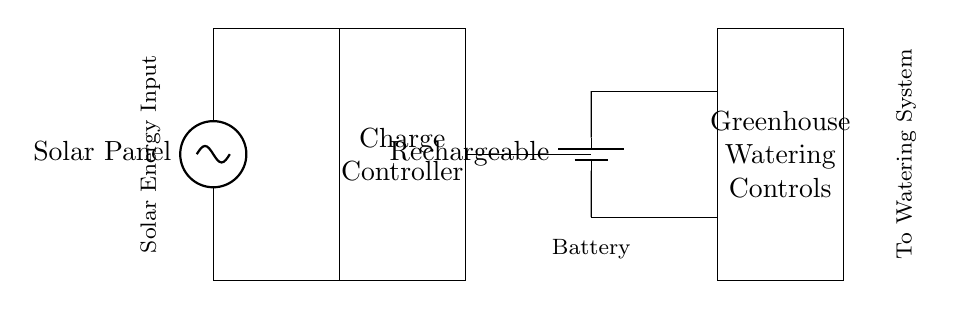What type of energy input does this system use? The system uses solar energy as indicated by the solar panel component at the start of the circuit.
Answer: Solar energy What component regulates the charging process? The charge controller component is responsible for regulating the charging from the solar panel to the battery, ensuring safe and efficient charging.
Answer: Charge controller What type of battery is indicated in the circuit? The circuit specifies a rechargeable battery, which is designed to be charged and discharged multiple times, making it suitable for the automated greenhouse system's needs.
Answer: Rechargeable How many main components are connected in this circuit? The circuit consists of four main components: the solar panel, charge controller, rechargeable battery, and greenhouse watering controls, all connected in sequence.
Answer: Four Which component connects the battery to the watering controls? The battery connects to the watering controls through direct wiring, shown by the lines extending from the battery to the controls, allowing power to flow toward the watering system.
Answer: Battery What is the function of the batteries in this circuit? The batteries store energy generated by the solar panel, providing a stable power supply to the greenhouse watering controls even when solar energy is not available.
Answer: Energy storage 